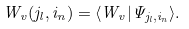<formula> <loc_0><loc_0><loc_500><loc_500>W _ { v } ( j _ { l } , i _ { n } ) = \langle W _ { v } | \Psi _ { j _ { l } , i _ { n } } \rangle .</formula> 